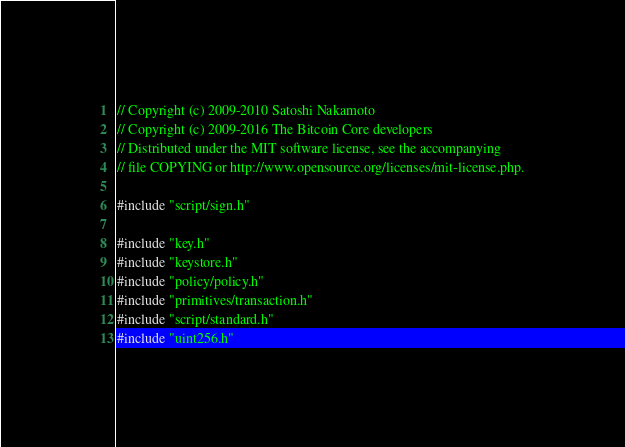<code> <loc_0><loc_0><loc_500><loc_500><_C++_>// Copyright (c) 2009-2010 Satoshi Nakamoto
// Copyright (c) 2009-2016 The Bitcoin Core developers
// Distributed under the MIT software license, see the accompanying
// file COPYING or http://www.opensource.org/licenses/mit-license.php.

#include "script/sign.h"

#include "key.h"
#include "keystore.h"
#include "policy/policy.h"
#include "primitives/transaction.h"
#include "script/standard.h"
#include "uint256.h"

</code> 